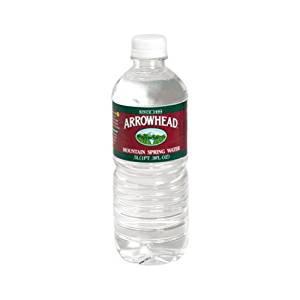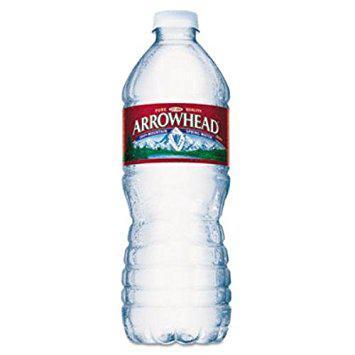The first image is the image on the left, the second image is the image on the right. Considering the images on both sides, is "Right and left images show a similarly shaped and sized non-stout bottle with a label and a white cap." valid? Answer yes or no. Yes. 